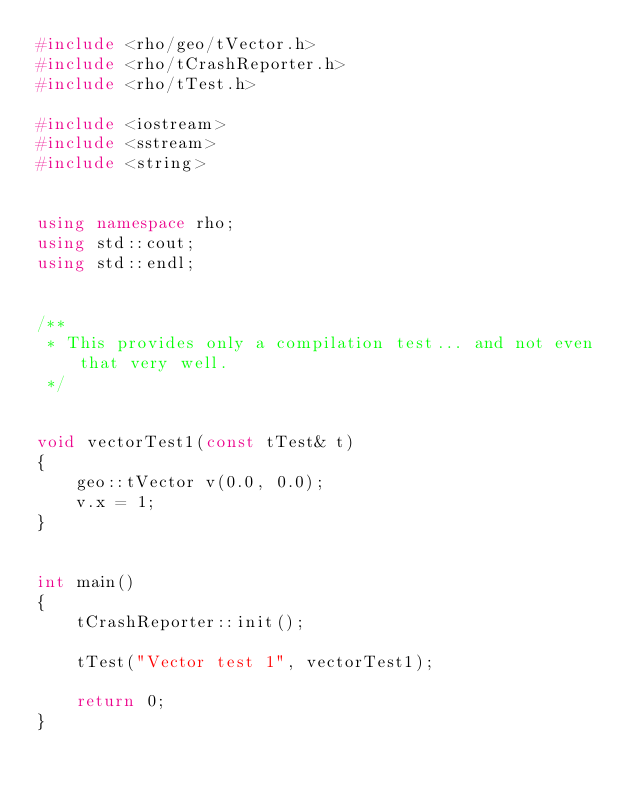<code> <loc_0><loc_0><loc_500><loc_500><_C++_>#include <rho/geo/tVector.h>
#include <rho/tCrashReporter.h>
#include <rho/tTest.h>

#include <iostream>
#include <sstream>
#include <string>


using namespace rho;
using std::cout;
using std::endl;


/**
 * This provides only a compilation test... and not even that very well.
 */


void vectorTest1(const tTest& t)
{
    geo::tVector v(0.0, 0.0);
    v.x = 1;
}


int main()
{
    tCrashReporter::init();

    tTest("Vector test 1", vectorTest1);

    return 0;
}
</code> 